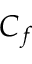<formula> <loc_0><loc_0><loc_500><loc_500>C _ { f }</formula> 